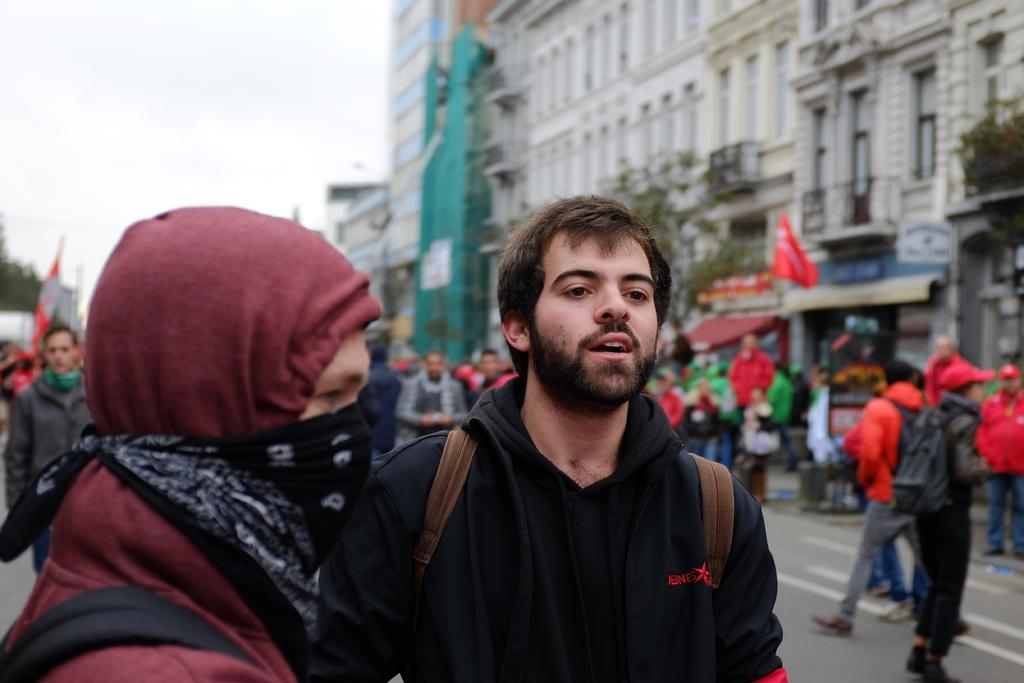How many people are in the image? There are persons in the image, but the exact number is not specified. What type of structure is visible in the image? There is a building in the image. What is visible at the top of the image? The sky is visible at the top of the image. What type of air is being judged by the person in the image? There is no person or air present in the image, so it is not possible to determine what, if any, air is being judged. 